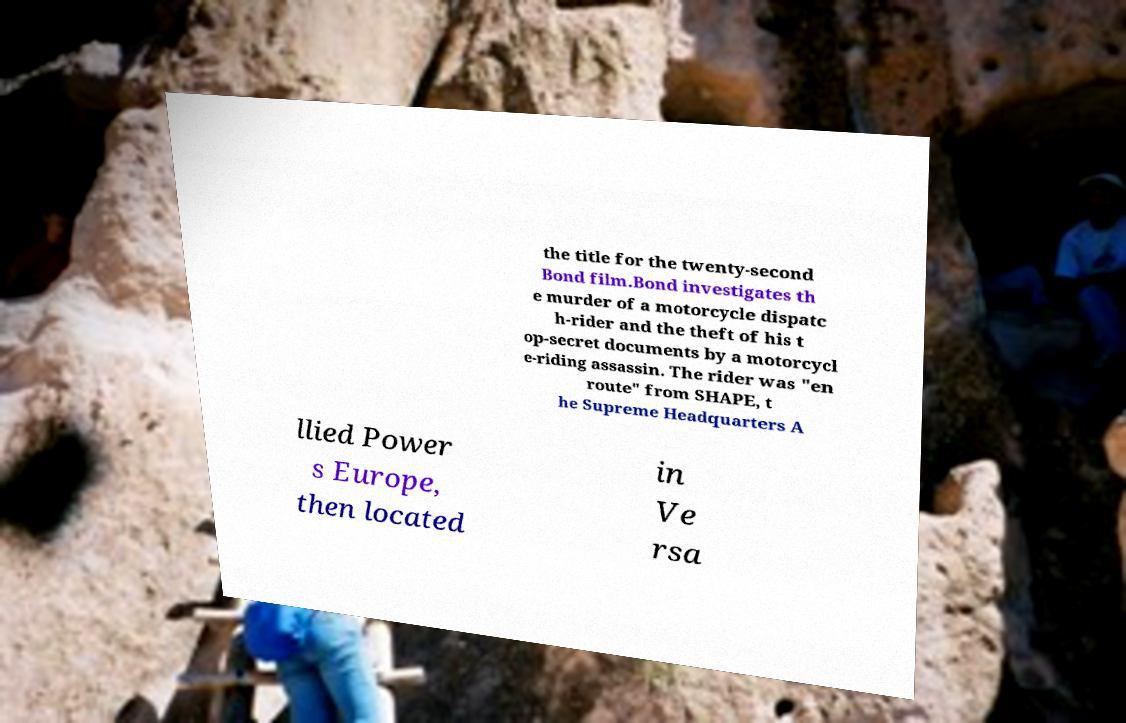Could you assist in decoding the text presented in this image and type it out clearly? the title for the twenty-second Bond film.Bond investigates th e murder of a motorcycle dispatc h-rider and the theft of his t op-secret documents by a motorcycl e-riding assassin. The rider was "en route" from SHAPE, t he Supreme Headquarters A llied Power s Europe, then located in Ve rsa 